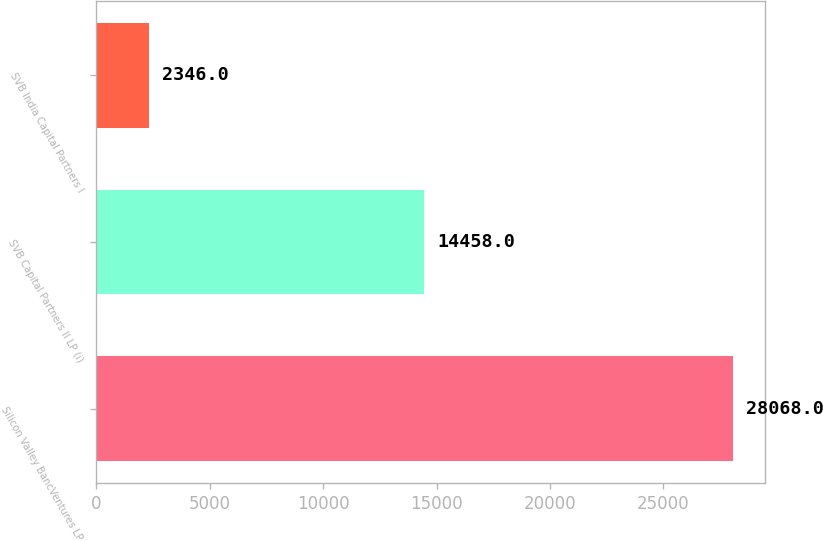Convert chart. <chart><loc_0><loc_0><loc_500><loc_500><bar_chart><fcel>Silicon Valley BancVentures LP<fcel>SVB Capital Partners II LP (i)<fcel>SVB India Capital Partners I<nl><fcel>28068<fcel>14458<fcel>2346<nl></chart> 